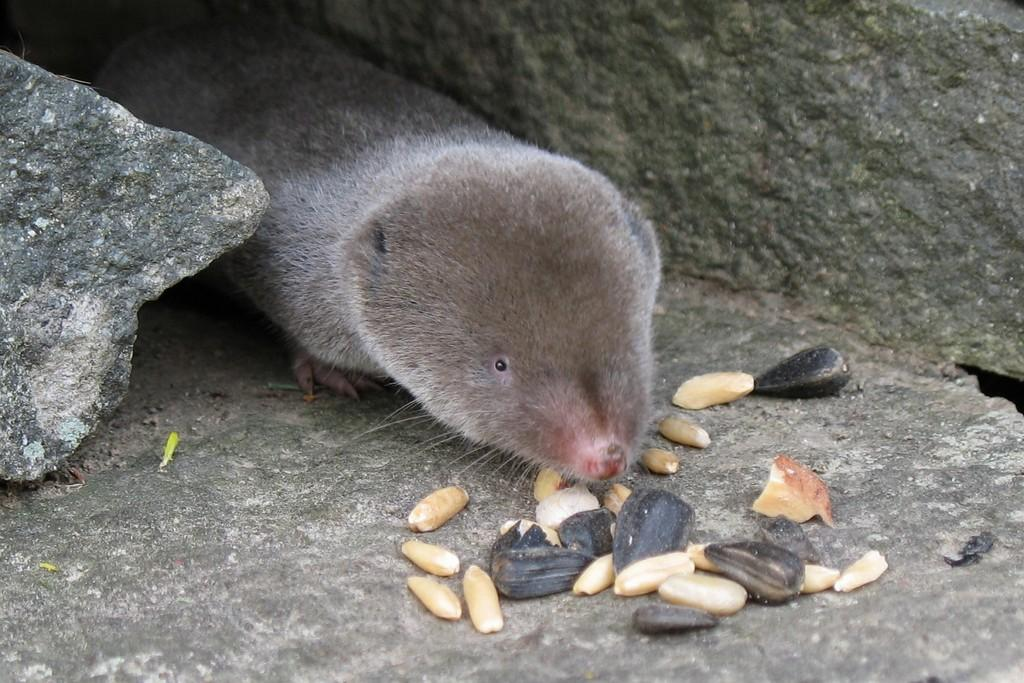What is the primary subject of the image? The primary subject of the image is mold. What other objects can be seen in the image? There are black seeds and stones visible in the image. How many frogs can be seen in the image? There are no frogs present in the image. What year is depicted in the image? The image does not depict a specific year. 